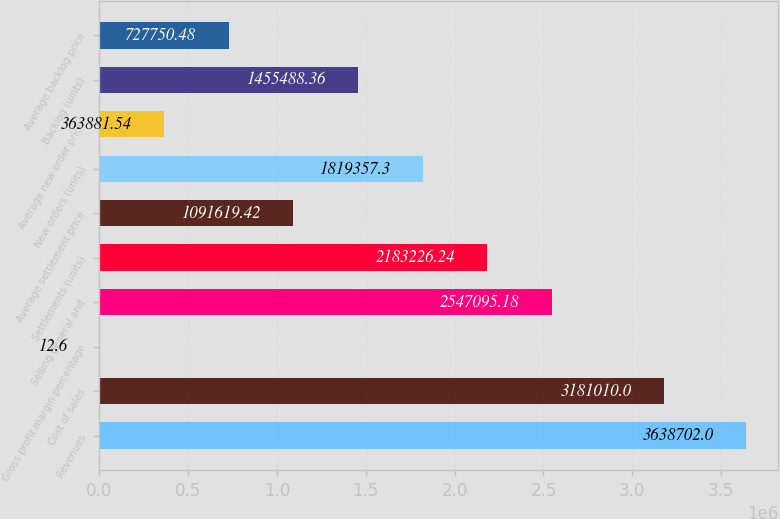<chart> <loc_0><loc_0><loc_500><loc_500><bar_chart><fcel>Revenues<fcel>Cost of sales<fcel>Gross profit margin percentage<fcel>Selling general and<fcel>Settlements (units)<fcel>Average settlement price<fcel>New orders (units)<fcel>Average new order price<fcel>Backlog (units)<fcel>Average backlog price<nl><fcel>3.6387e+06<fcel>3.18101e+06<fcel>12.6<fcel>2.5471e+06<fcel>2.18323e+06<fcel>1.09162e+06<fcel>1.81936e+06<fcel>363882<fcel>1.45549e+06<fcel>727750<nl></chart> 